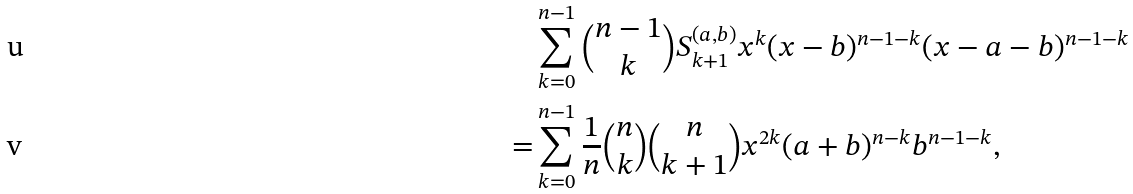Convert formula to latex. <formula><loc_0><loc_0><loc_500><loc_500>& \sum _ { k = 0 } ^ { n - 1 } \binom { n - 1 } { k } S _ { k + 1 } ^ { ( a , b ) } x ^ { k } ( x - b ) ^ { n - 1 - k } ( x - a - b ) ^ { n - 1 - k } \\ = & \sum _ { k = 0 } ^ { n - 1 } \frac { 1 } { n } \binom { n } { k } \binom { n } { k + 1 } x ^ { 2 k } ( a + b ) ^ { n - k } b ^ { n - 1 - k } ,</formula> 